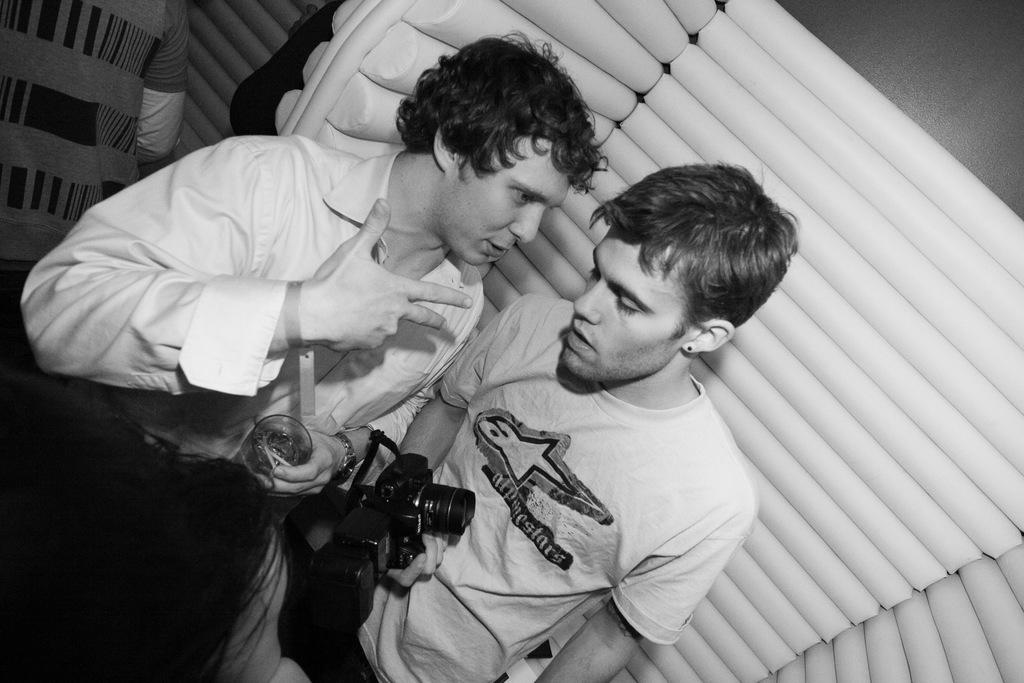How many people are in the image? There are two persons in the image. Where is one of the persons located in the image? One person is standing on the right side. What is the person on the right side holding in their hand? The person on the right side is holding a camera in their hand. What type of rhythm is the person on the left side practicing in the image? There is no person on the left side in the image, and therefore no rhythm can be observed. 